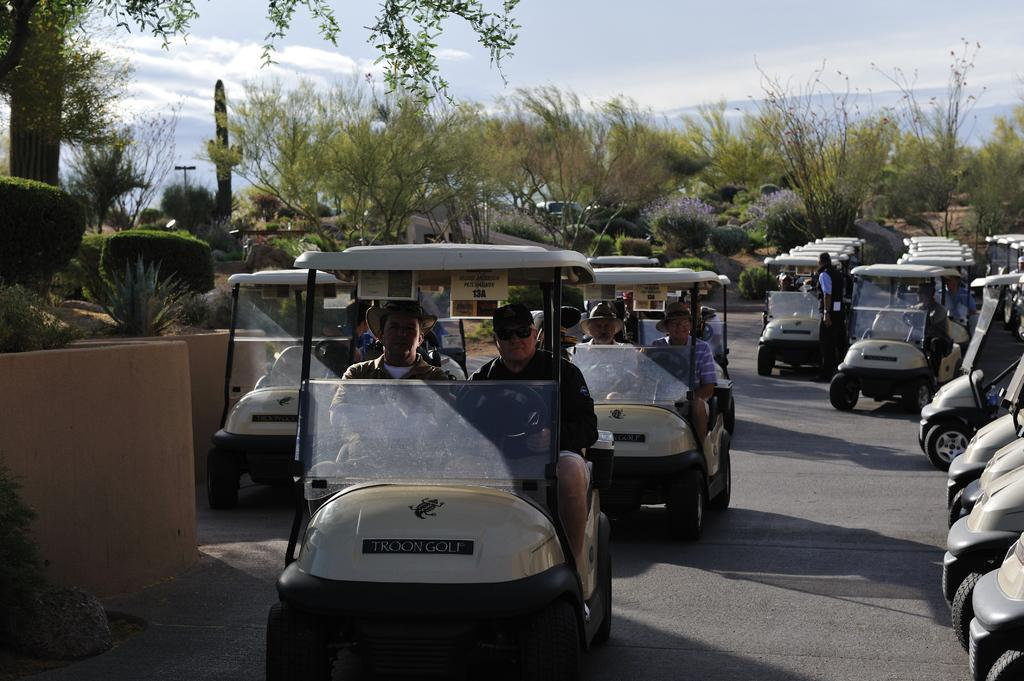How many people can be seen in the image? There are many people in the image. What are the people doing in the image? The people are riding vehicles. What type of vegetation is visible beside the vehicles? There are trees and shrubs beside the vehicles. What is visible in the background of the image? There are trees in the background of the image. What can be seen at the top of the image? The sky is visible at the top of the image. What type of grain is being harvested by the people in the image? There is no grain being harvested in the image; the people are riding vehicles. How many crows can be seen in the image? There are no crows present in the image. 